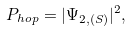Convert formula to latex. <formula><loc_0><loc_0><loc_500><loc_500>P _ { h o p } = | \Psi _ { 2 , ( S ) } | ^ { 2 } ,</formula> 